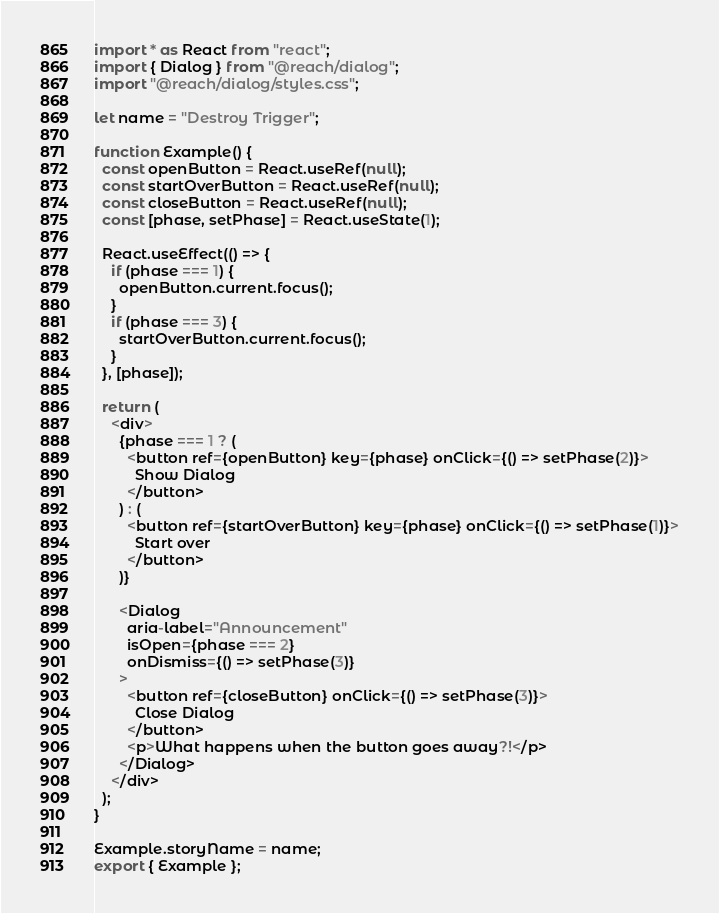Convert code to text. <code><loc_0><loc_0><loc_500><loc_500><_JavaScript_>import * as React from "react";
import { Dialog } from "@reach/dialog";
import "@reach/dialog/styles.css";

let name = "Destroy Trigger";

function Example() {
  const openButton = React.useRef(null);
  const startOverButton = React.useRef(null);
  const closeButton = React.useRef(null);
  const [phase, setPhase] = React.useState(1);

  React.useEffect(() => {
    if (phase === 1) {
      openButton.current.focus();
    }
    if (phase === 3) {
      startOverButton.current.focus();
    }
  }, [phase]);

  return (
    <div>
      {phase === 1 ? (
        <button ref={openButton} key={phase} onClick={() => setPhase(2)}>
          Show Dialog
        </button>
      ) : (
        <button ref={startOverButton} key={phase} onClick={() => setPhase(1)}>
          Start over
        </button>
      )}

      <Dialog
        aria-label="Announcement"
        isOpen={phase === 2}
        onDismiss={() => setPhase(3)}
      >
        <button ref={closeButton} onClick={() => setPhase(3)}>
          Close Dialog
        </button>
        <p>What happens when the button goes away?!</p>
      </Dialog>
    </div>
  );
}

Example.storyName = name;
export { Example };
</code> 